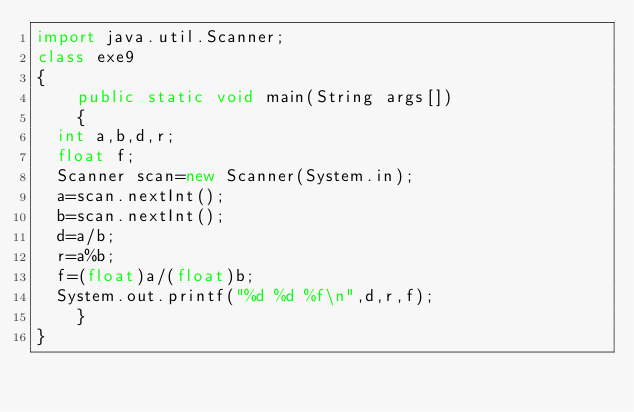Convert code to text. <code><loc_0><loc_0><loc_500><loc_500><_Java_>import java.util.Scanner;
class exe9
{
    public static void main(String args[])
    {
	int a,b,d,r;
	float f;
	Scanner scan=new Scanner(System.in);
	a=scan.nextInt();
	b=scan.nextInt();
	d=a/b;
	r=a%b;
	f=(float)a/(float)b;
	System.out.printf("%d %d %f\n",d,r,f);
    }
}</code> 